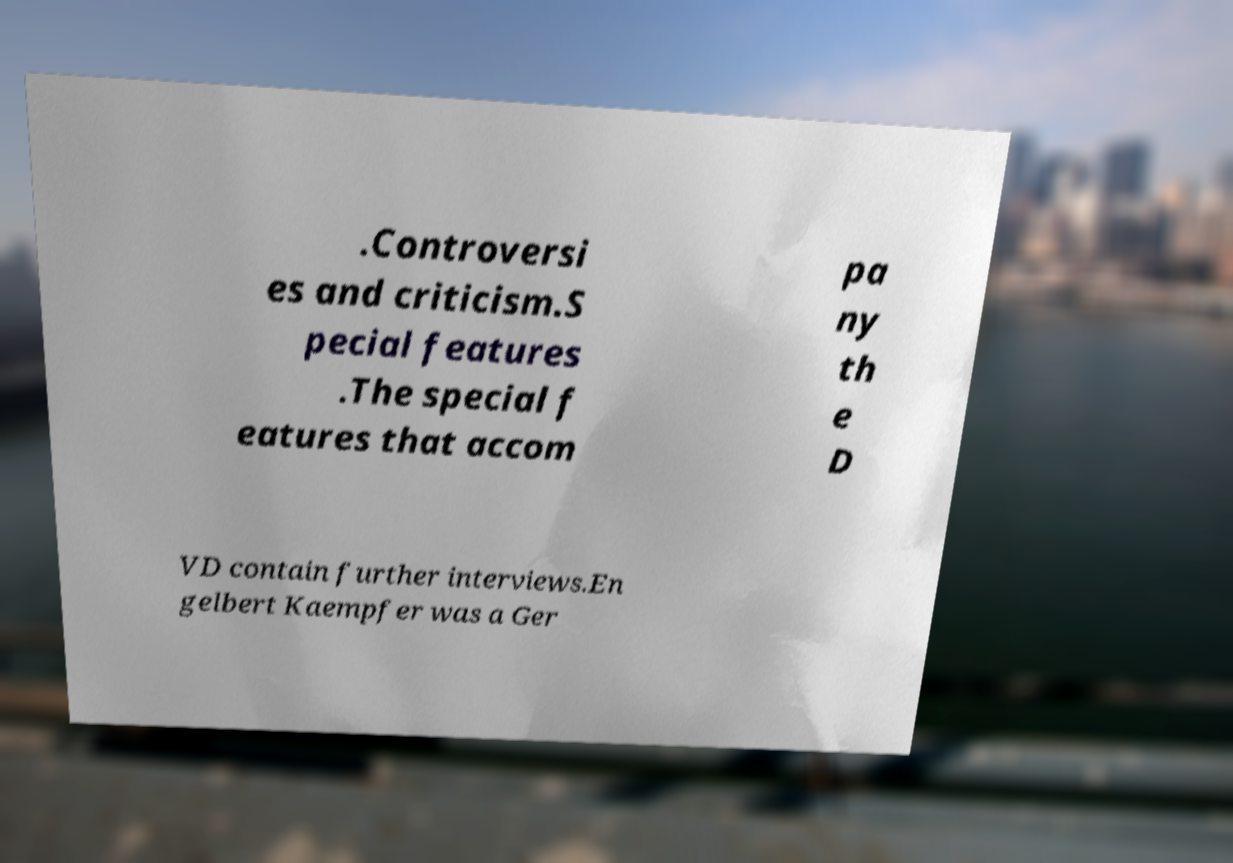For documentation purposes, I need the text within this image transcribed. Could you provide that? .Controversi es and criticism.S pecial features .The special f eatures that accom pa ny th e D VD contain further interviews.En gelbert Kaempfer was a Ger 